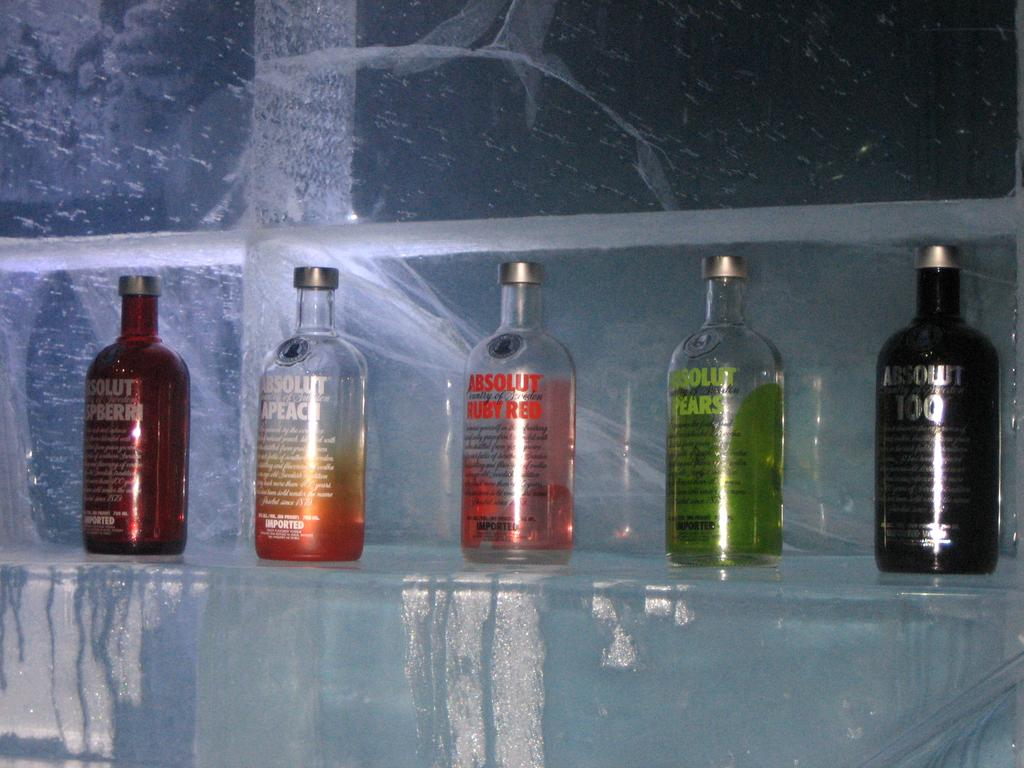Provide a one-sentence caption for the provided image. Several different flavors of Absolut Vodka are on a shelf made of ice. 